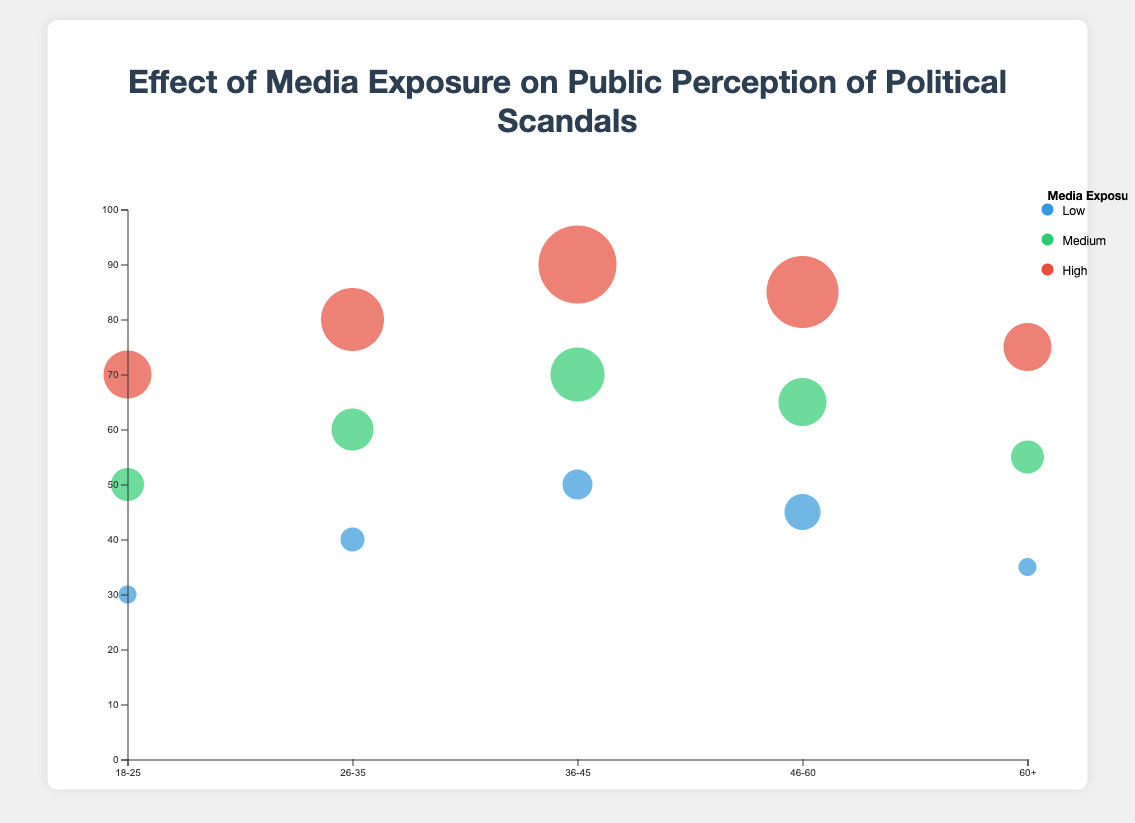What is the title of the chart? The title of the chart is written above the chart. It is "Effect of Media Exposure on Public Perception of Political Scandals".
Answer: Effect of Media Exposure on Public Perception of Political Scandals What does the x-axis represent? The x-axis label underneath the axis reads "Age Group", indicating that the x-axis represents different age groups.
Answer: Age Group Which age group has the lowest perception index with low media exposure? The circle with the smallest perception index among those with low media exposure (colored in blue) on the axis corresponds to the age group "18-25".
Answer: 18-25 How does the perception index for the "36-45" age group change with different levels of media exposure? For the age group "36-45", the perception index increases as media exposure goes from Low (50) to Medium (70) to High (90).
Answer: Increases What age group has the largest bubble for high media exposure? The size of the bubbles increases with the age group. The largest bubble which corresponds to the largest perception index for high media exposure (red) is in the "36-45" age group.
Answer: 36-45 Which age group has the most significant change in perception index between low and high media exposure? To determine the significant change, subtract low media exposure perception index from high media exposure for each group. "18-25" (70 - 30 = 40), "26-35" (80 - 40 = 40), "36-45" (90 - 50 = 40), "46-60" (85 - 45 = 40), "60+" (75 - 35 = 40). All changes are the same.
Answer: Tied Which group has the highest perception index for medium media exposure? By identifying the green bubbles for each age group and checking their positions on y-axis, the "36-45" age group has the highest perception index for medium media exposure (70).
Answer: 36-45 Is there any age group where the perception index decreases with higher media exposure? By observing the chart, for every age group, the perception index increases as media exposure increases from Low to High. No age group's perception index decreases with higher media exposure.
Answer: No How many total data points are there in the chart? By counting, each age group has 3 points (Low, Medium, High), and there are 5 age groups. Therefore, 5 age groups * 3 points = 15 data points.
Answer: 15 